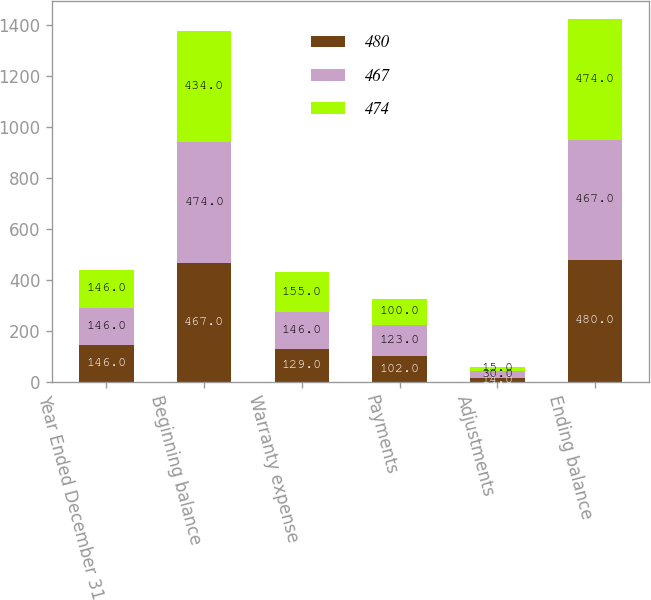<chart> <loc_0><loc_0><loc_500><loc_500><stacked_bar_chart><ecel><fcel>Year Ended December 31<fcel>Beginning balance<fcel>Warranty expense<fcel>Payments<fcel>Adjustments<fcel>Ending balance<nl><fcel>480<fcel>146<fcel>467<fcel>129<fcel>102<fcel>14<fcel>480<nl><fcel>467<fcel>146<fcel>474<fcel>146<fcel>123<fcel>30<fcel>467<nl><fcel>474<fcel>146<fcel>434<fcel>155<fcel>100<fcel>15<fcel>474<nl></chart> 